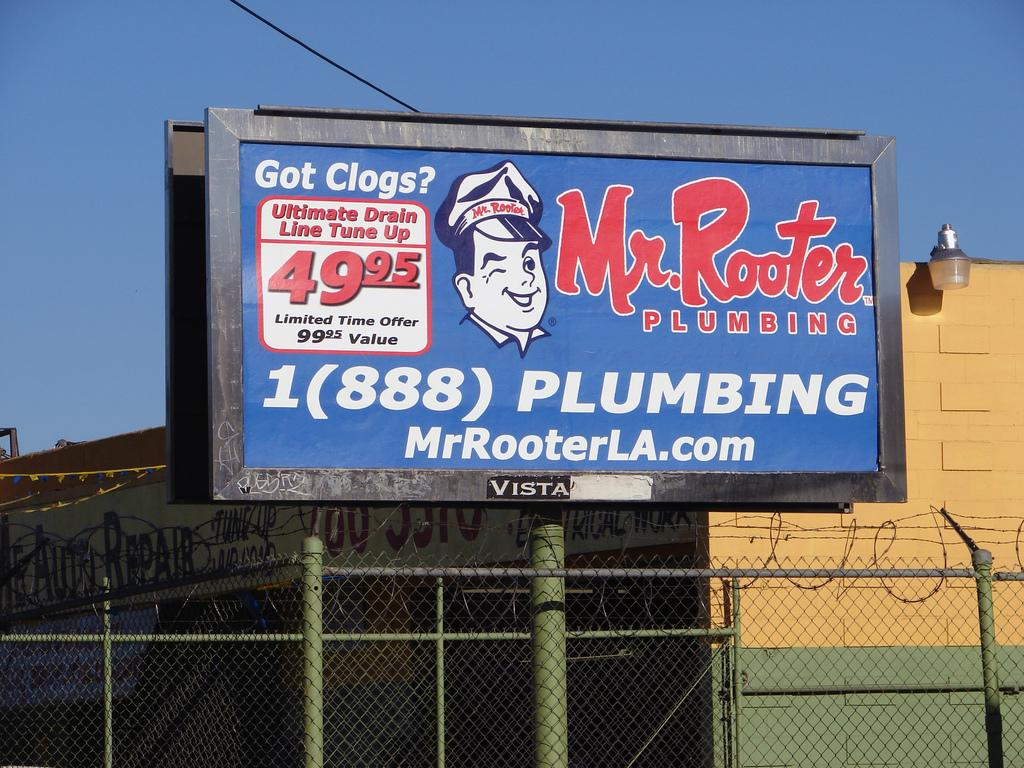<image>
Share a concise interpretation of the image provided. A blue, red and white billboard promoting Mr. Rooter Plumbing. 